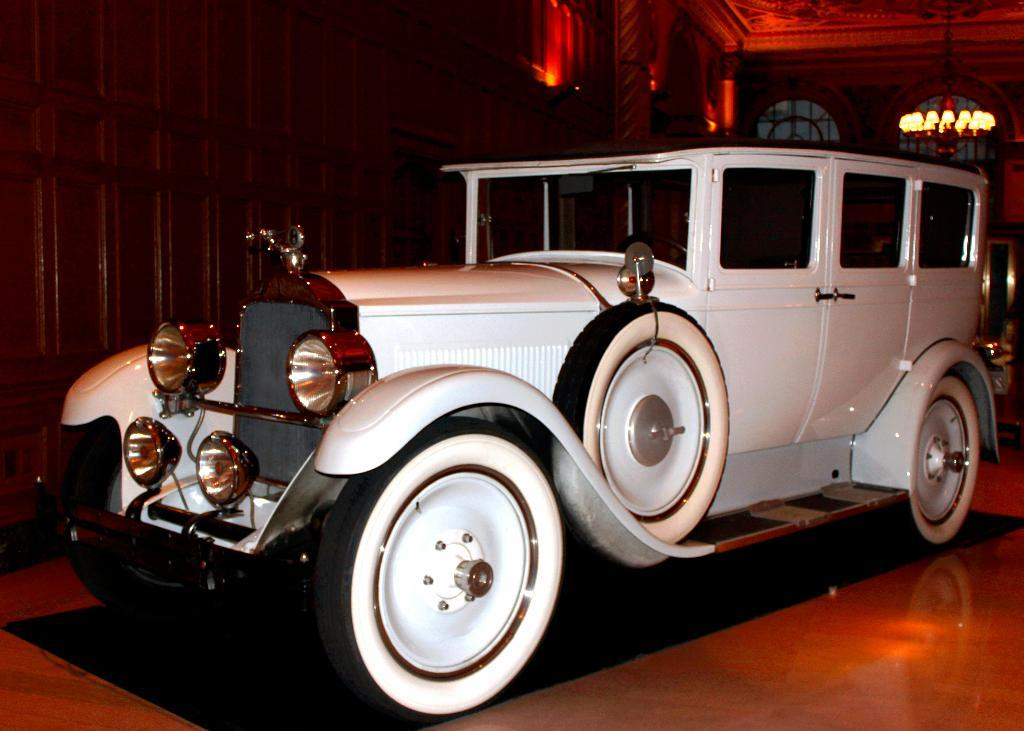Where was the image taken? The image was taken indoors. What is the main subject of the image? There is a white color car in the center of the image. How is the car positioned in the image? The car is parked on the ground. What can be seen in the background of the image? There is a roof, a chandelier, windows, and a wall visible in the background of the image. What type of shirt is the person wearing during the discussion in the image? There is no person or discussion present in the image; it features a parked white color car indoors. What word is written on the wall in the image? There is no word visible on the wall in the image. 